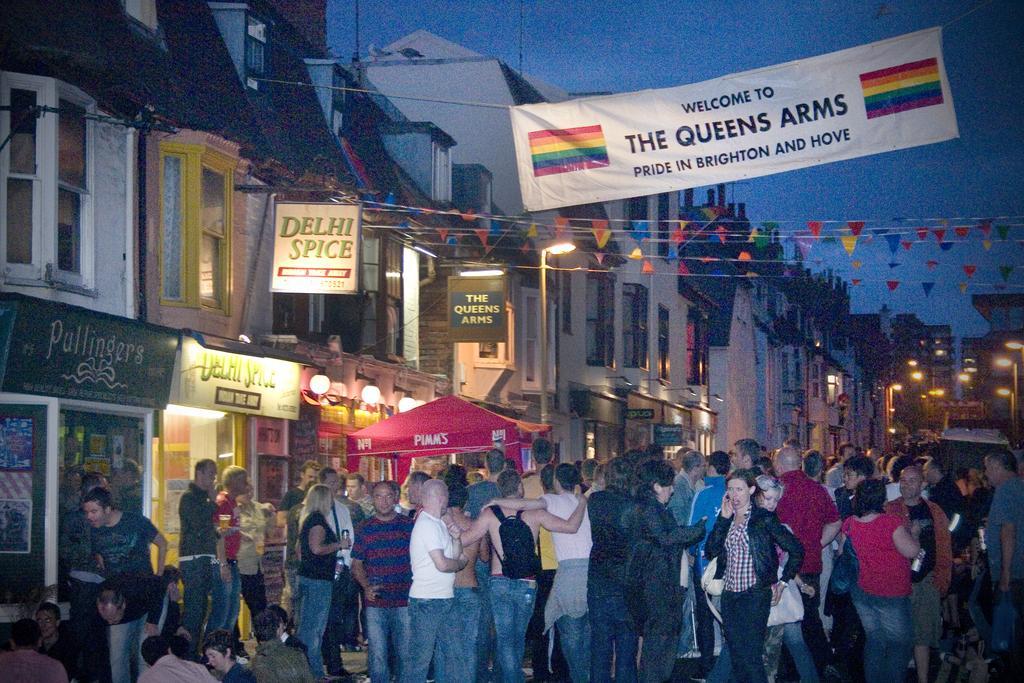How would you summarize this image in a sentence or two? In this image we can see buildings with windows, light poles, stores, banners and we can also see people standing. 